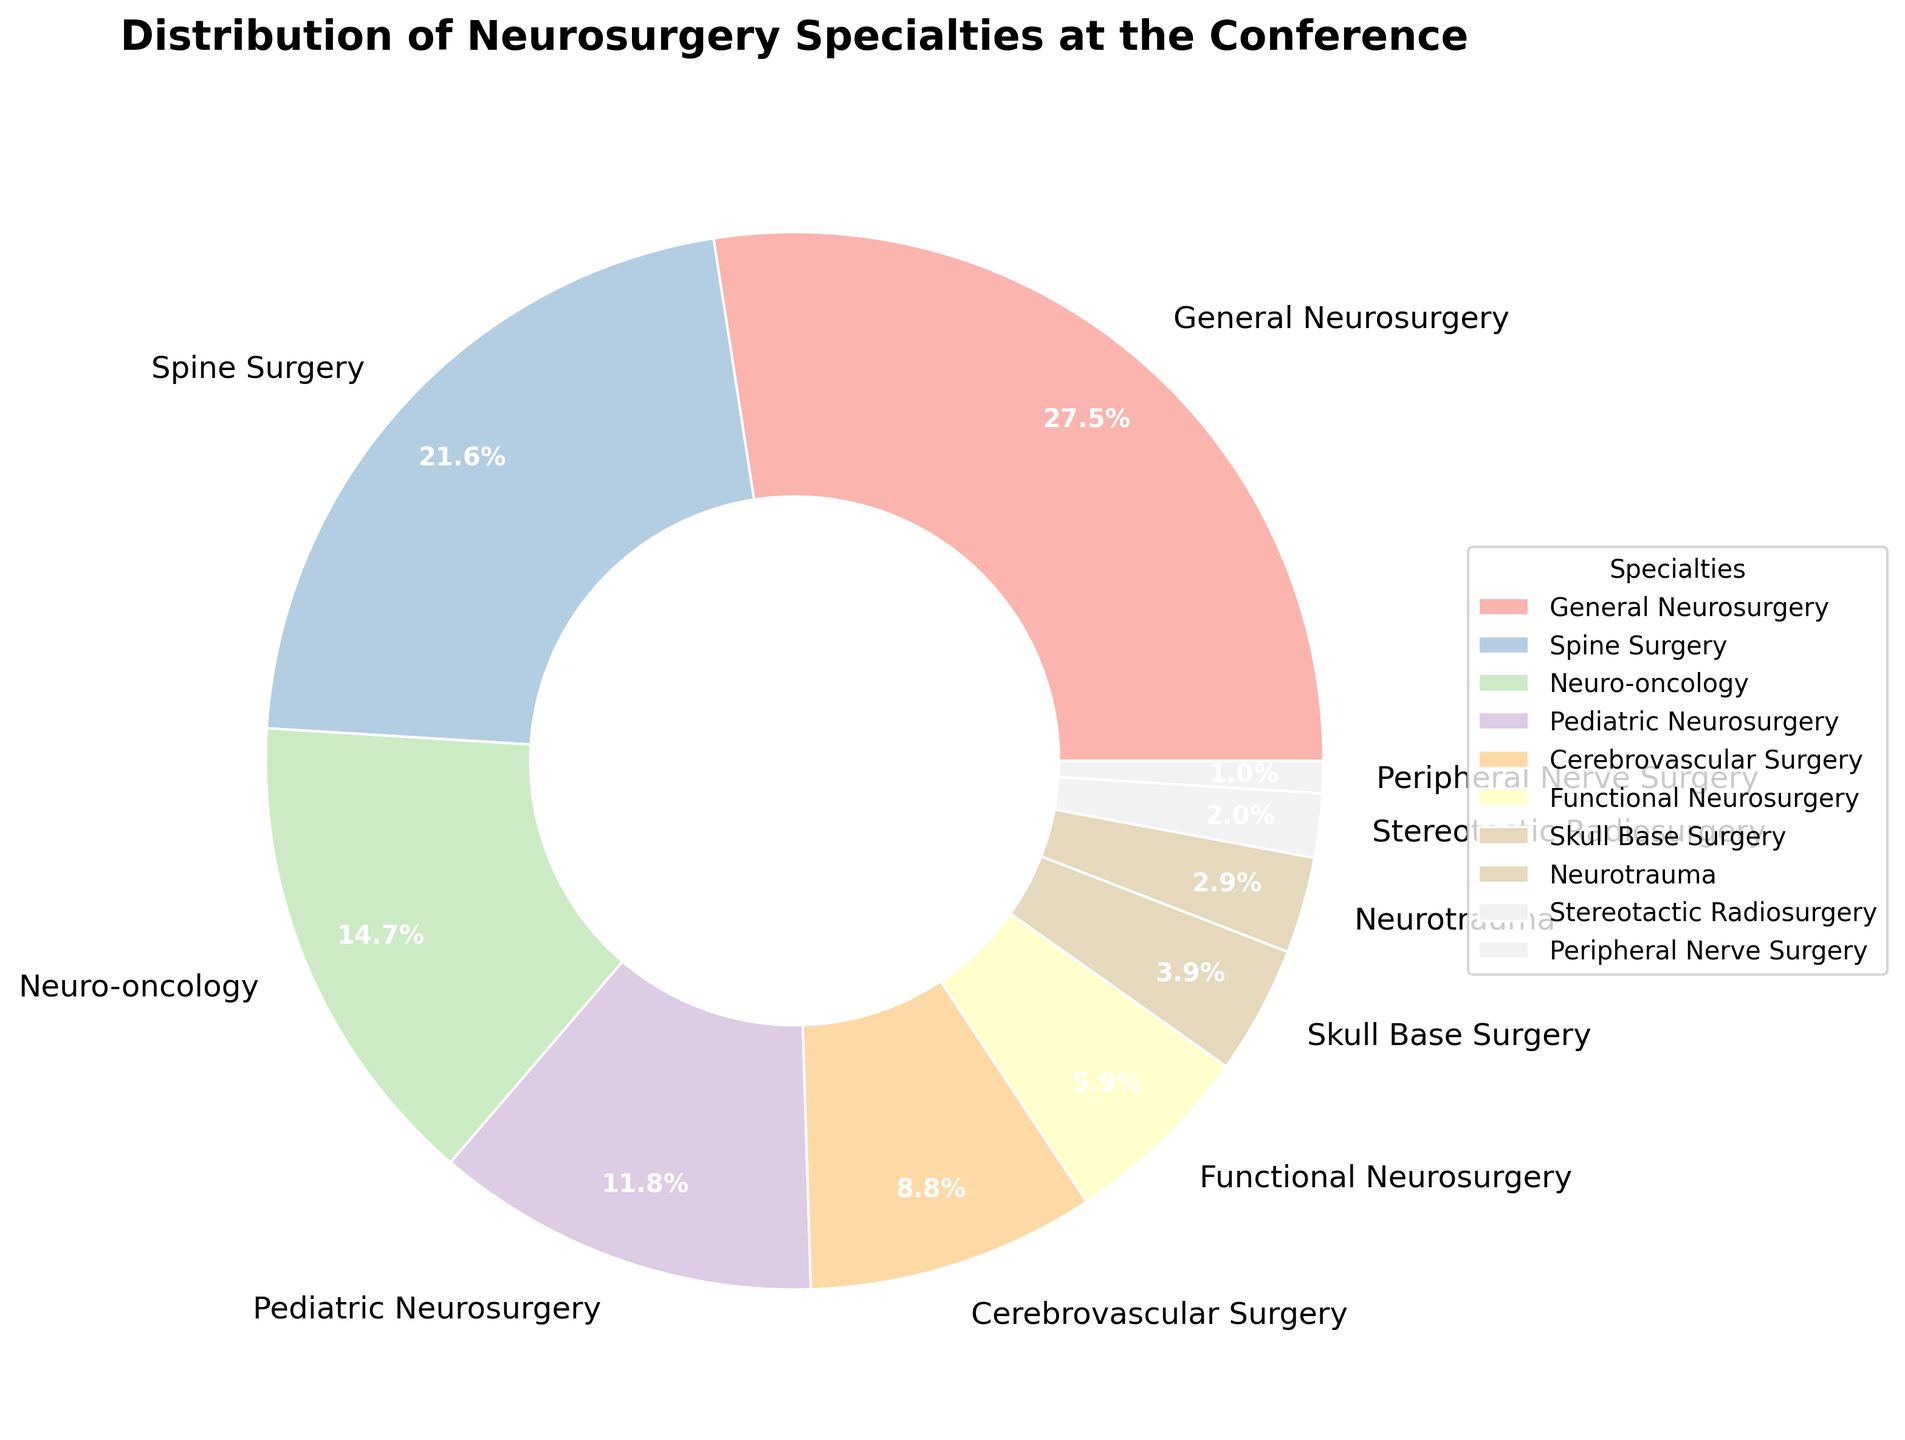What percentage of the specialties is General Neurosurgery? Locate the section labeled "General Neurosurgery" in the pie chart to find its percentage. It shows 28%.
Answer: 28% Which specialty has the lowest representation at the conference? The pie chart shows each specialty with their respective percentages. The smallest section, 1%, represents Peripheral Nerve Surgery.
Answer: Peripheral Nerve Surgery Compare the percentage of Spine Surgery to that of Neuro-oncology. Which one has a higher representation? Locate the sections for Spine Surgery and Neuro-oncology. Spine Surgery has 22%, while Neuro-oncology has 15%. Therefore, Spine Surgery has a higher representation.
Answer: Spine Surgery What is the combined percentage of Pediatric Neurosurgery and Functional Neurosurgery? Find the percentages for Pediatric Neurosurgery (12%) and Functional Neurosurgery (6%), then add them together: 12% + 6% = 18%.
Answer: 18% Is the total percentage of Cerebrovascular Surgery and Skull Base Surgery greater than Neuro-oncology? Locate the percentages: Cerebrovascular Surgery (9%), Skull Base Surgery (4%), and Neuro-oncology (15%). Sum the percentages of Cerebrovascular and Skull Base (9% + 4% = 13%) and compare to 15%. 13% is less than 15%.
Answer: No Which three specialties together make up more than half (50%) of the total representation at the conference? Check the highest percentages: General Neurosurgery (28%), Spine Surgery (22%), and Neuro-oncology (15%). Add these: 28% + 22% + 15% = 65%. These three specialties together exceed 50%.
Answer: General Neurosurgery, Spine Surgery, Neuro-oncology If you were to combine Neurotrauma and Stereotactic Radiosurgery, what percentage would they represent together? Find percentages for Neurotrauma (3%) and Stereotactic Radiosurgery (2%), then add them: 3% + 2% = 5%.
Answer: 5% By how much does the representation of Spine Surgery surpass that of Functional Neurosurgery? Spine Surgery is 22% and Functional Neurosurgery is 6%. Subtract to find the difference: 22% - 6% = 16%.
Answer: 16% What specialty has twice the representation of Neurotrauma? Neurotrauma has 3%. Find the specialty that has twice this percentage (3% * 2 = 6%). Functional Neurosurgery matches this at 6%.
Answer: Functional Neurosurgery 